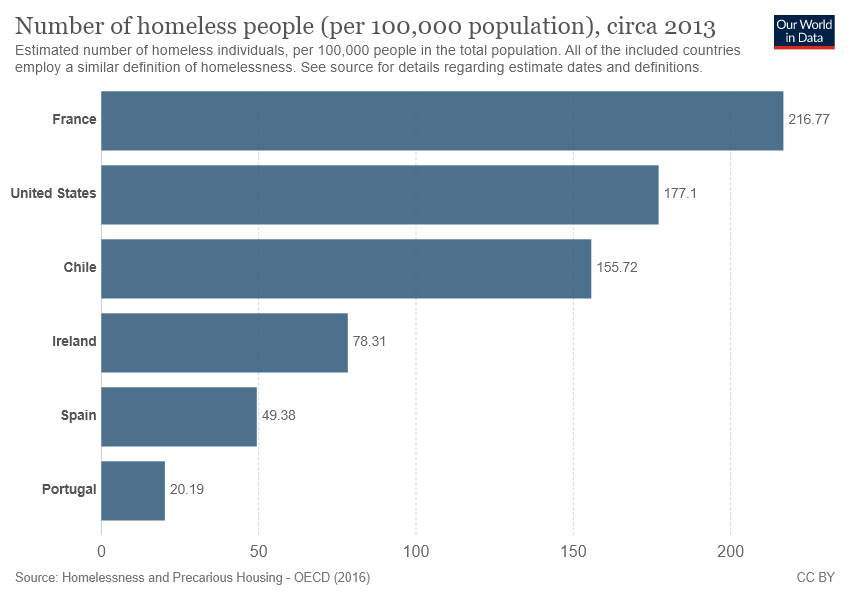Identify some key points in this picture. France has the longest bar in the world. 